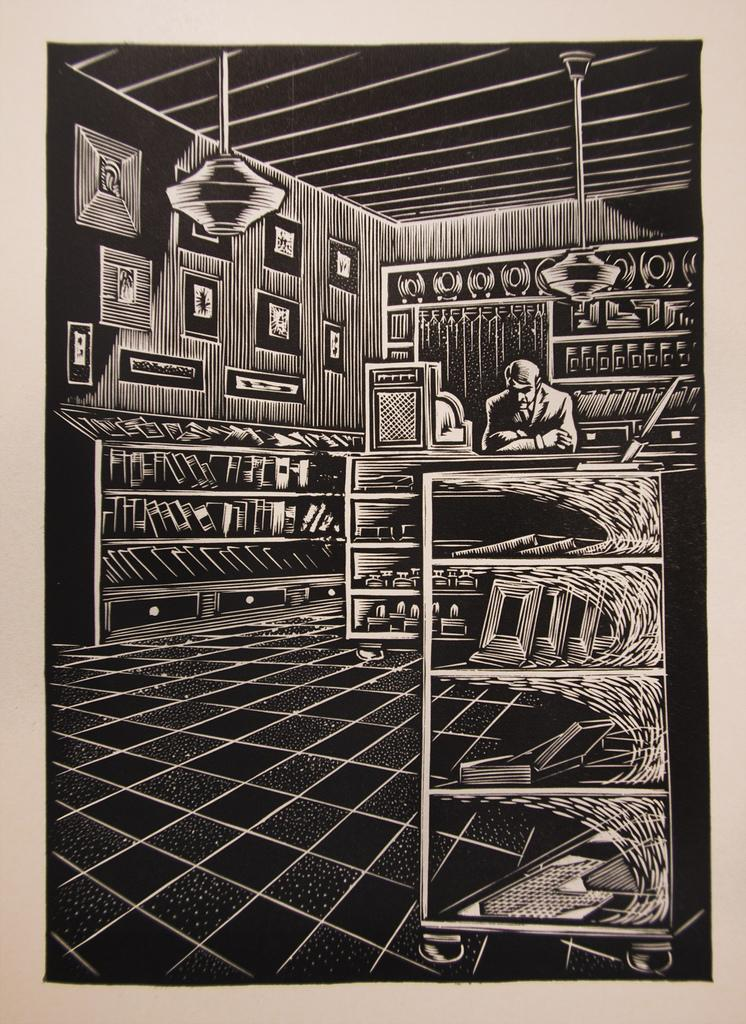<image>
Share a concise interpretation of the image provided. A black and white graphic drawing without text on it 